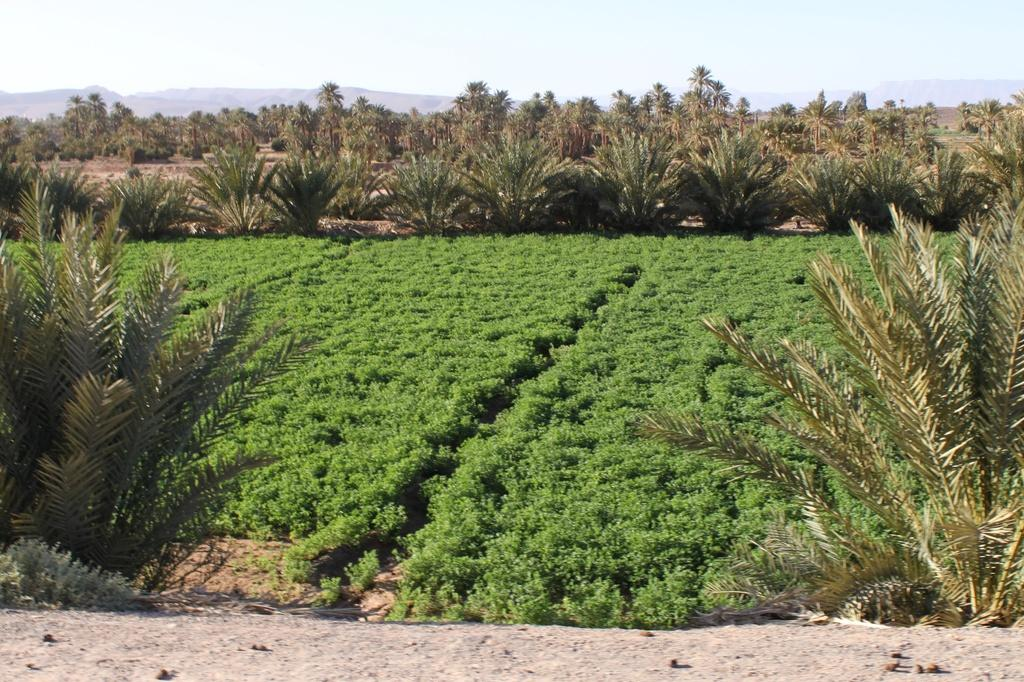What type of vegetation is on the ground in the image? There are plants on the ground in the image. What can be seen in the background of the image? There are trees in the background of the image. What part of the natural environment is visible in the image? The sky is visible in the image. What type of wristwatch is visible on the tree in the image? There is no wristwatch present in the image; it features plants, trees, and the sky. Can you describe the paper airplane flying in the background of the image? There is no paper airplane present in the image; it only features plants, trees, and the sky. 